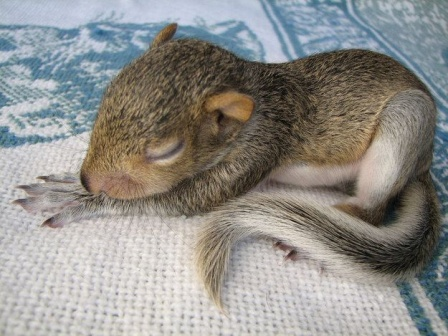If the baby squirrel could talk, what would it say about its cozy blanket? If the baby squirrel could talk, it might say: 'This blanket is the coziest spot I've ever found! The soft, woven threads hug me gently, and the beautiful blue and white patterns make me feel like I'm resting on a piece of art. Every snuggle on this blanket feels like a warm embrace, keeping me safe and comfortable as I dream of all the fun I'll have when I wake up. It's my perfect little sanctuary in this big, wondrous world.' 